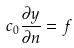<formula> <loc_0><loc_0><loc_500><loc_500>c _ { 0 } \frac { \partial y } { \partial n } = f</formula> 